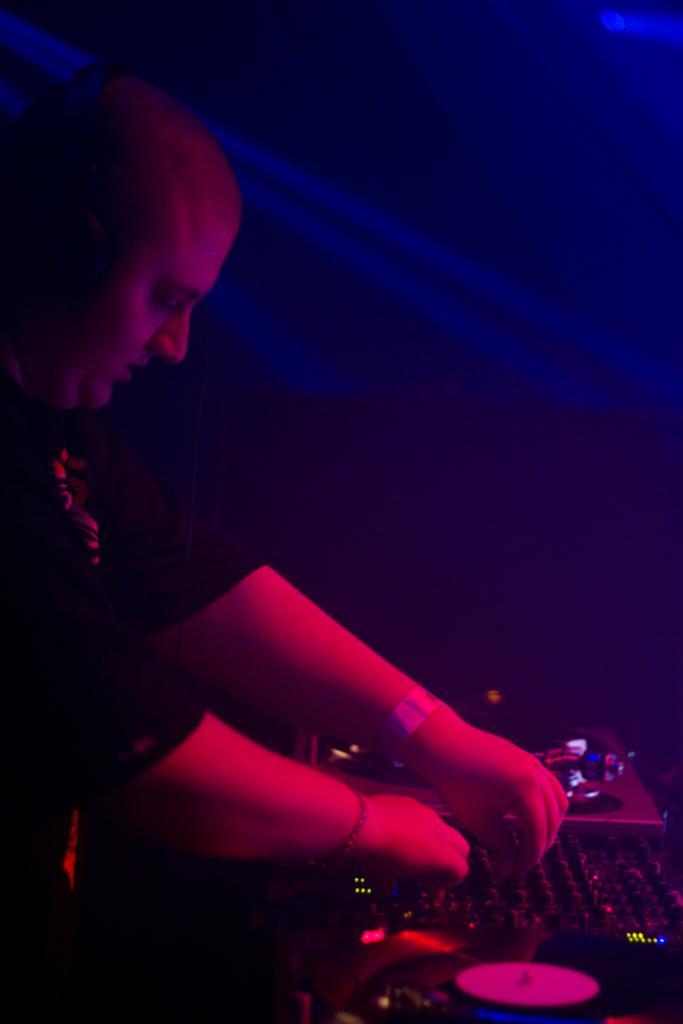Could you give a brief overview of what you see in this image? In this image we can see a man playing dj. 